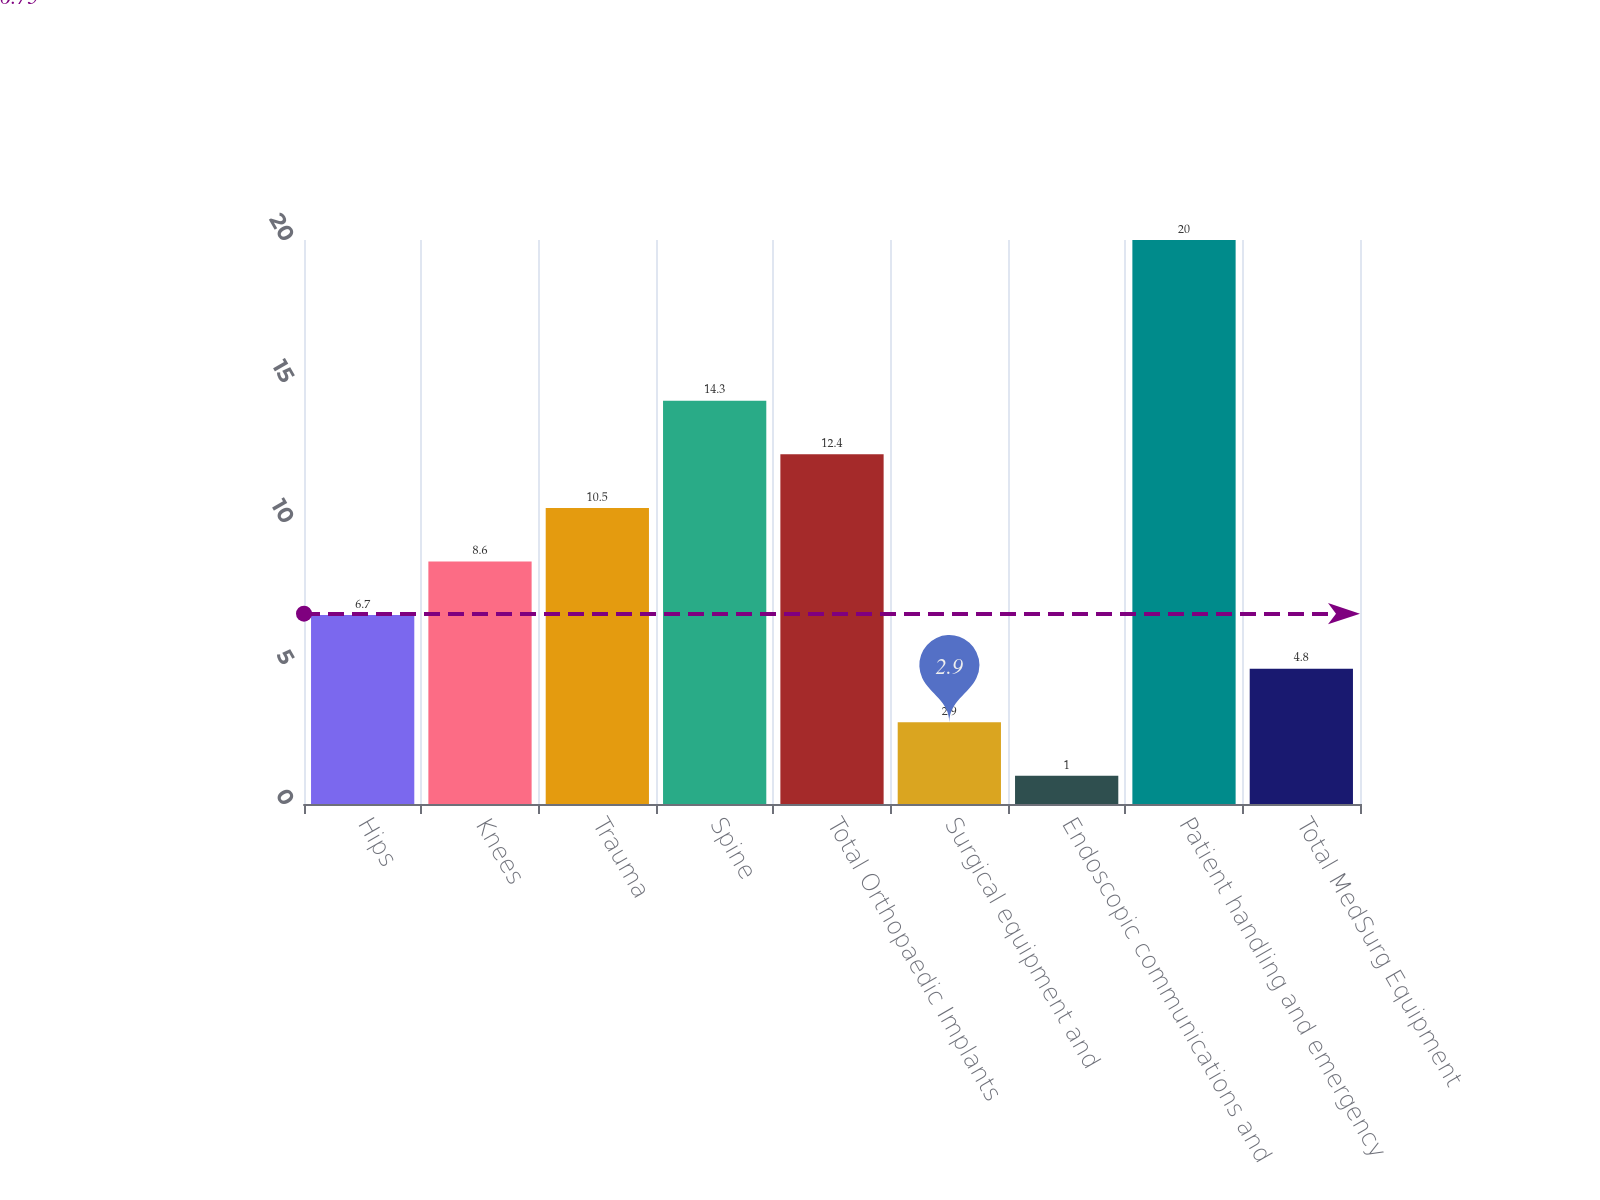Convert chart. <chart><loc_0><loc_0><loc_500><loc_500><bar_chart><fcel>Hips<fcel>Knees<fcel>Trauma<fcel>Spine<fcel>Total Orthopaedic Implants<fcel>Surgical equipment and<fcel>Endoscopic communications and<fcel>Patient handling and emergency<fcel>Total MedSurg Equipment<nl><fcel>6.7<fcel>8.6<fcel>10.5<fcel>14.3<fcel>12.4<fcel>2.9<fcel>1<fcel>20<fcel>4.8<nl></chart> 